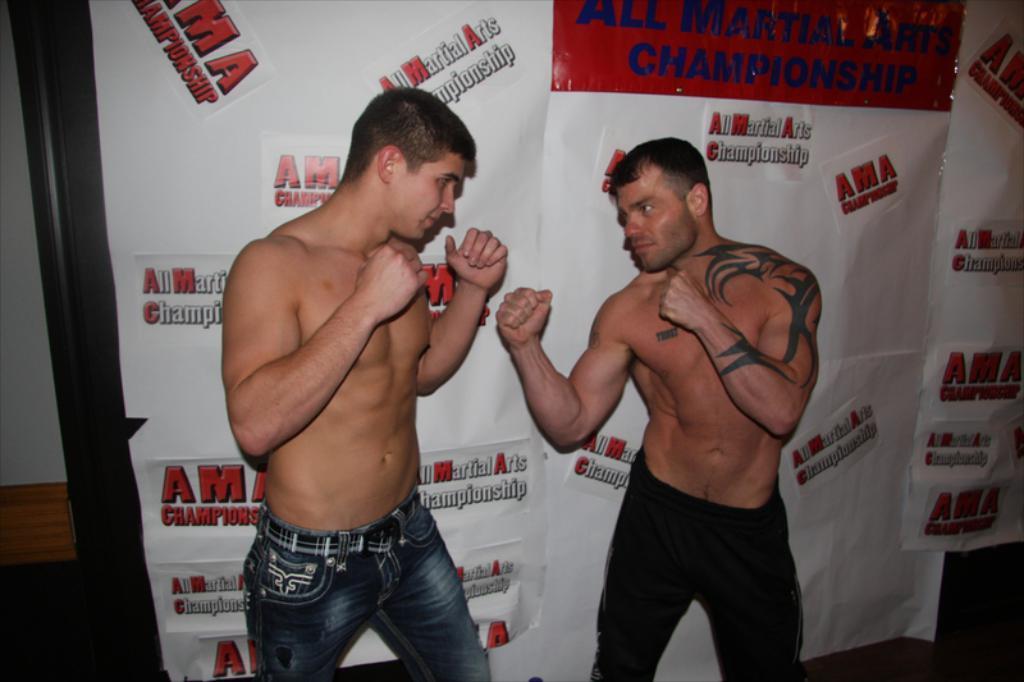Can you describe this image briefly? In this image there are two persons in fighting position. In the background there are posters. Some part of wall is also visible. 